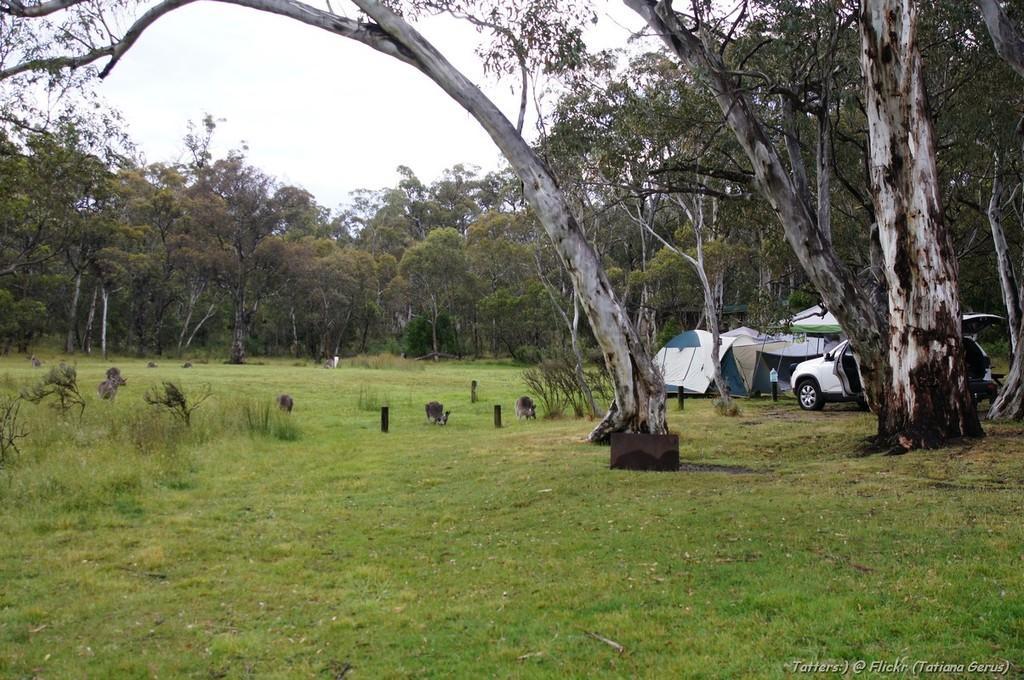What type of temporary shelters can be seen in the image? There are tents in the image. What vehicle is visible on the right side of the image? There is a car on the right side of the image. What type of vegetation is present in the image? There are trees in the image. What type of terrain is visible in the image? There is grassland in the image. How many friends are sitting on the tank in the image? There is no tank present in the image, and therefore no friends can be seen sitting on it. What type of fruit is being used as a decoration in the image? There is no fruit, specifically quince, present in the image. 